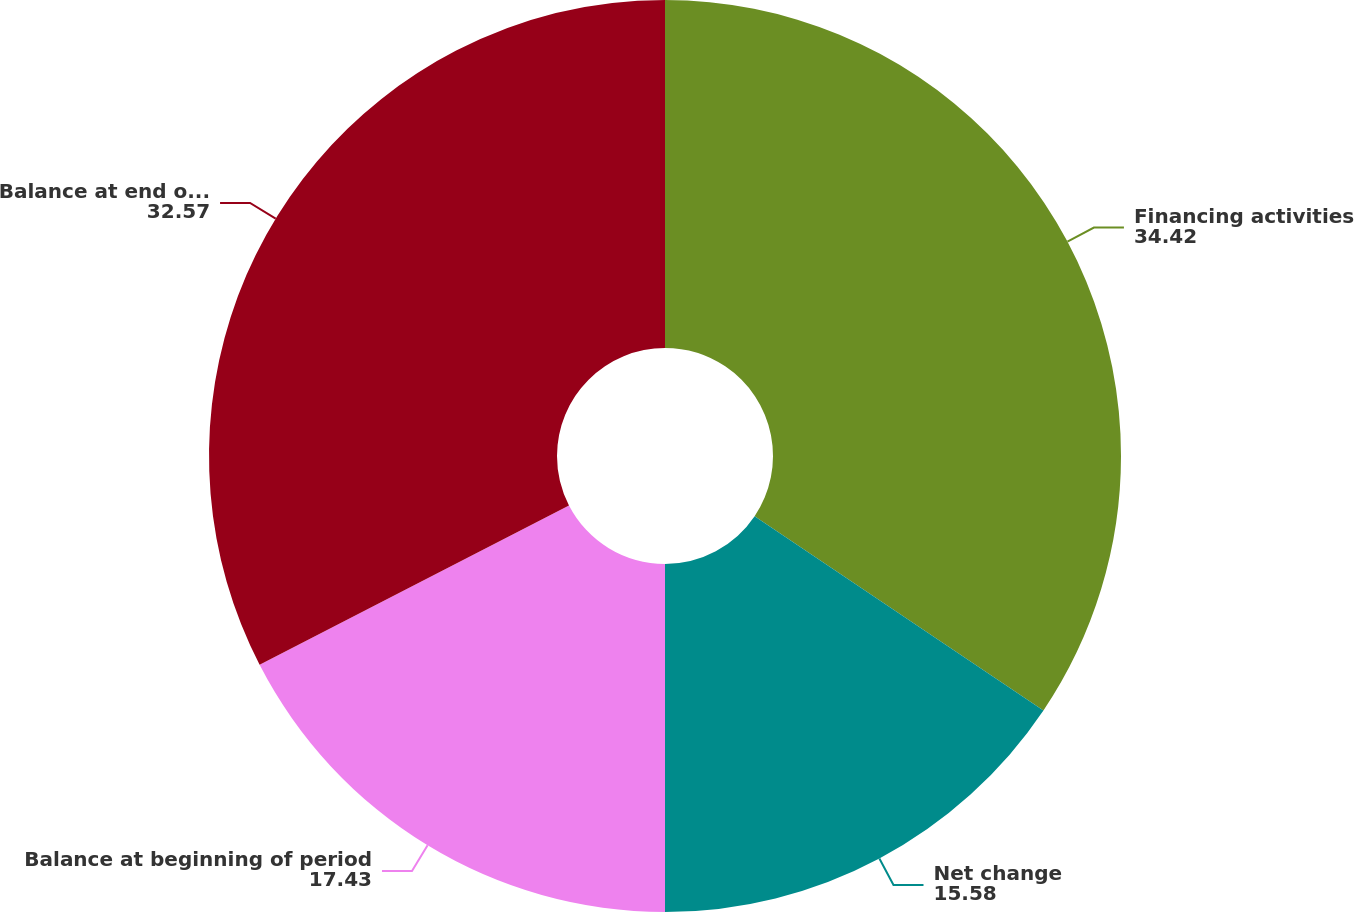Convert chart. <chart><loc_0><loc_0><loc_500><loc_500><pie_chart><fcel>Financing activities<fcel>Net change<fcel>Balance at beginning of period<fcel>Balance at end of period<nl><fcel>34.42%<fcel>15.58%<fcel>17.43%<fcel>32.57%<nl></chart> 